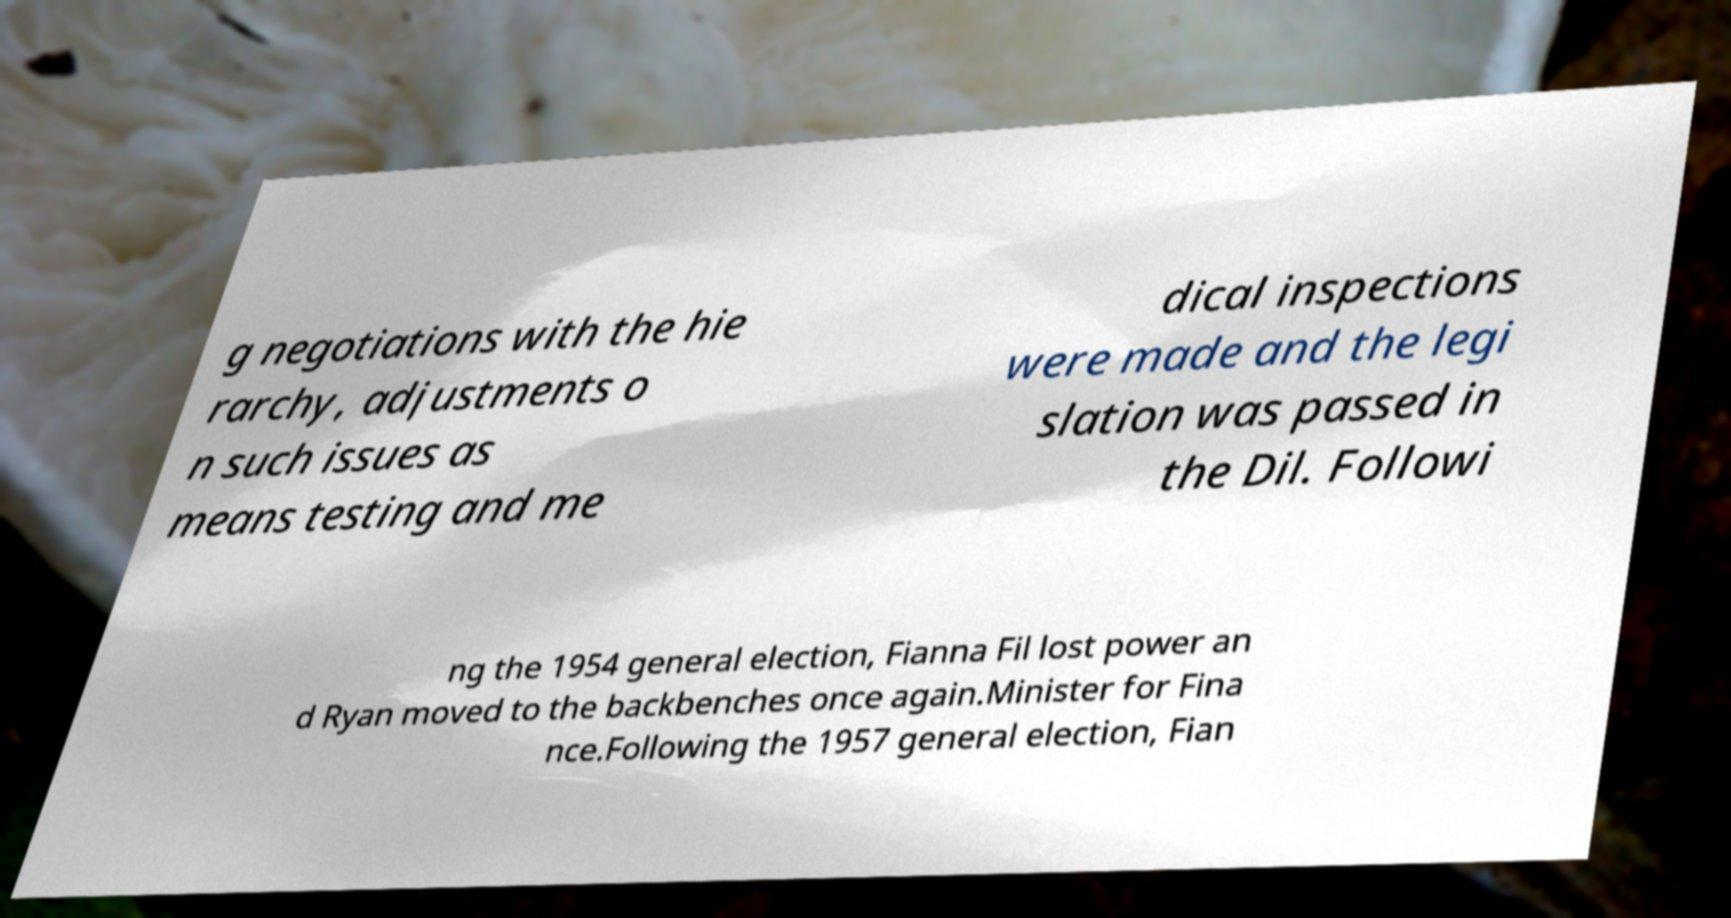Could you assist in decoding the text presented in this image and type it out clearly? g negotiations with the hie rarchy, adjustments o n such issues as means testing and me dical inspections were made and the legi slation was passed in the Dil. Followi ng the 1954 general election, Fianna Fil lost power an d Ryan moved to the backbenches once again.Minister for Fina nce.Following the 1957 general election, Fian 